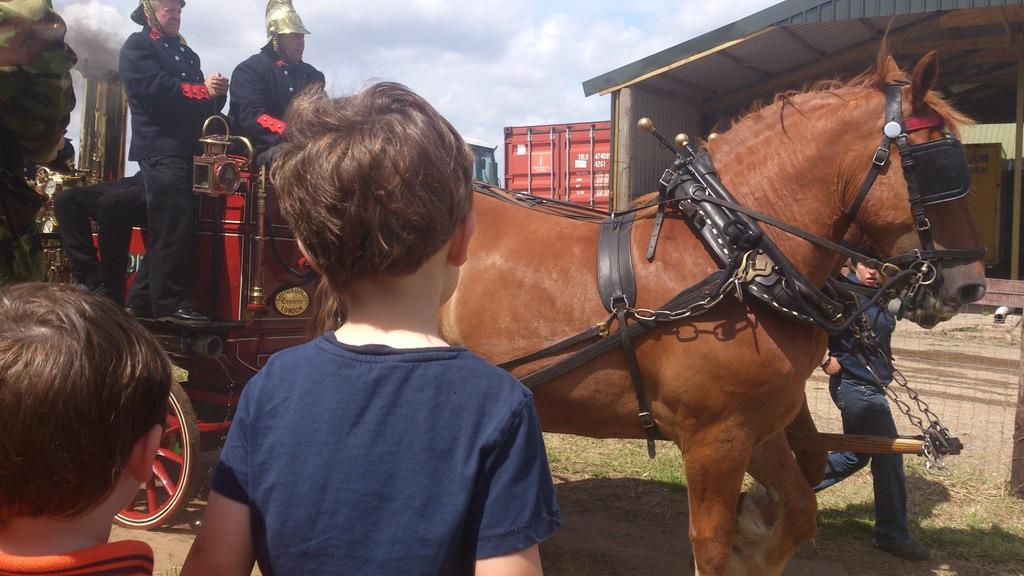How many kids are in the image? There are two kids in the image. What are the kids doing in the image? The kids are standing in front of a horse. Can you describe the background of the image? There are other people in the background of the image, and the sky is visible. What type of screw can be seen holding the paper to the boat in the image? There is no screw, paper, or boat present in the image. 